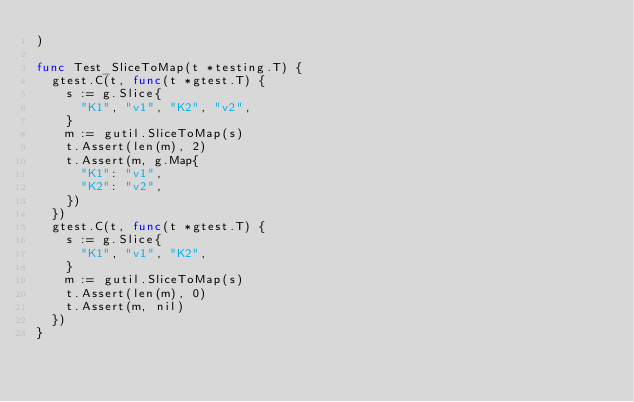<code> <loc_0><loc_0><loc_500><loc_500><_Go_>)

func Test_SliceToMap(t *testing.T) {
	gtest.C(t, func(t *gtest.T) {
		s := g.Slice{
			"K1", "v1", "K2", "v2",
		}
		m := gutil.SliceToMap(s)
		t.Assert(len(m), 2)
		t.Assert(m, g.Map{
			"K1": "v1",
			"K2": "v2",
		})
	})
	gtest.C(t, func(t *gtest.T) {
		s := g.Slice{
			"K1", "v1", "K2",
		}
		m := gutil.SliceToMap(s)
		t.Assert(len(m), 0)
		t.Assert(m, nil)
	})
}
</code> 